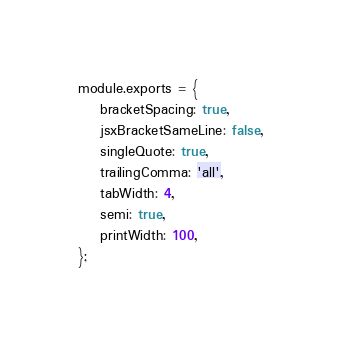<code> <loc_0><loc_0><loc_500><loc_500><_JavaScript_>module.exports = {
    bracketSpacing: true,
    jsxBracketSameLine: false,
    singleQuote: true,
    trailingComma: 'all',
    tabWidth: 4,
    semi: true,
    printWidth: 100,
};
</code> 